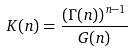<formula> <loc_0><loc_0><loc_500><loc_500>K ( n ) = \frac { ( \Gamma ( n ) ) ^ { n - 1 } } { G ( n ) }</formula> 